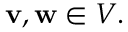Convert formula to latex. <formula><loc_0><loc_0><loc_500><loc_500>v , w \in V .</formula> 